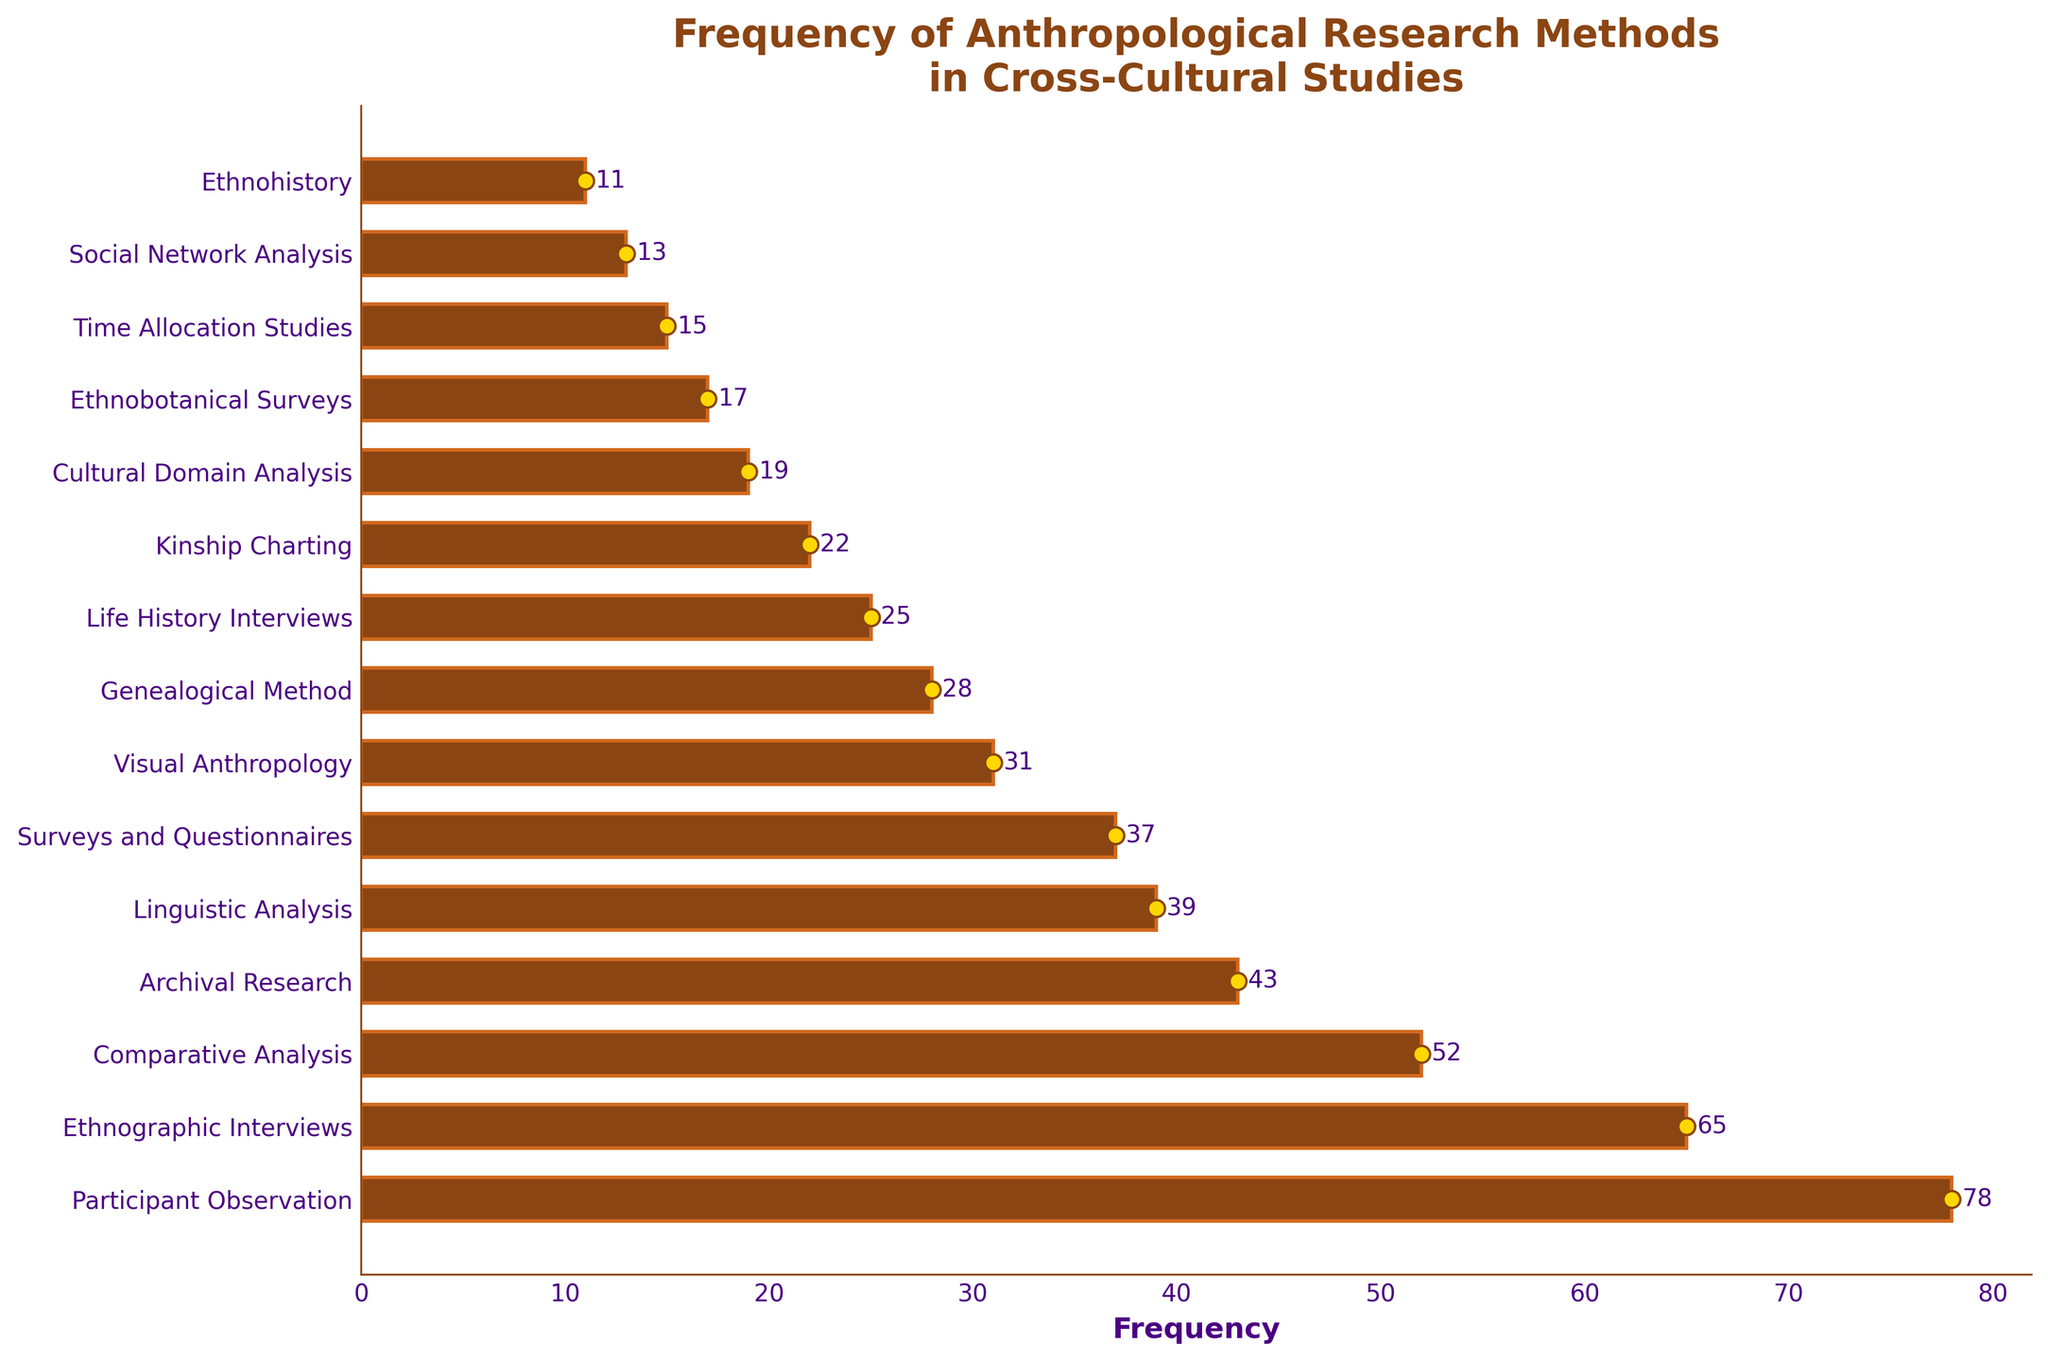Which research method has the highest frequency? The bar chart shows the frequency for each method, and the tallest bar corresponds to the method with the highest frequency. The "Participant Observation" bar is the tallest at a value of 78.
Answer: Participant Observation Which research method has the lowest frequency? The shortest bar represents the method with the lowest frequency. The "Ethnohistory" method has the smallest bar with a frequency of 11.
Answer: Ethnohistory What is the frequency difference between Participant Observation and Ethnohistory? We need to subtract the frequency of Ethnohistory (11) from Participant Observation (78). So, 78 - 11 = 67.
Answer: 67 How many methods have a frequency greater than 50? By observing the chart, identify and count the bars with a frequency greater than 50. These are "Participant Observation," "Ethnographic Interviews," and "Comparative Analysis," making a total of 3 methods.
Answer: 3 What is the average frequency of the top three methods? First, sum the frequencies of the top three methods: Participant Observation (78), Ethnographic Interviews (65), and Comparative Analysis (52). The sum is 78 + 65 + 52 = 195. Now, divide by 3: 195 / 3 = 65.
Answer: 65 Which method has a frequency closest to 30? Visually scanning the bars, "Visual Anthropology" has a frequency of 31, which is closest to 30.
Answer: Visual Anthropology Does Archival Research have a higher or lower frequency than Surveys and Questionnaires? Compare the heights of the bars for these two methods. Archival Research has a frequency of 43, while Surveys and Questionnaires have a frequency of 37. Thus, Archival Research has a higher frequency.
Answer: Higher What is the combined frequency of Linguistic Analysis, Surveys and Questionnaires, and Visual Anthropology? Add the frequencies of these three methods: Linguistic Analysis (39), Surveys and Questionnaires (37), and Visual Anthropology (31). The sum is 39 + 37 + 31 = 107.
Answer: 107 How many methods have frequencies less than 20? Count the methods whose bars have frequencies less than 20. These are "Cultural Domain Analysis," "Ethnobotanical Surveys," "Time Allocation Studies," "Social Network Analysis," and "Ethnohistory," making 5 methods in total.
Answer: 5 Is the frequency of Kinship Charting more than double that of Social Network Analysis? Check the frequencies: Kinship Charting is 22, and Social Network Analysis is 13. Double of 13 is 26, which is greater than 22, so Kinship Charting is not more than double Social Network Analysis.
Answer: No 